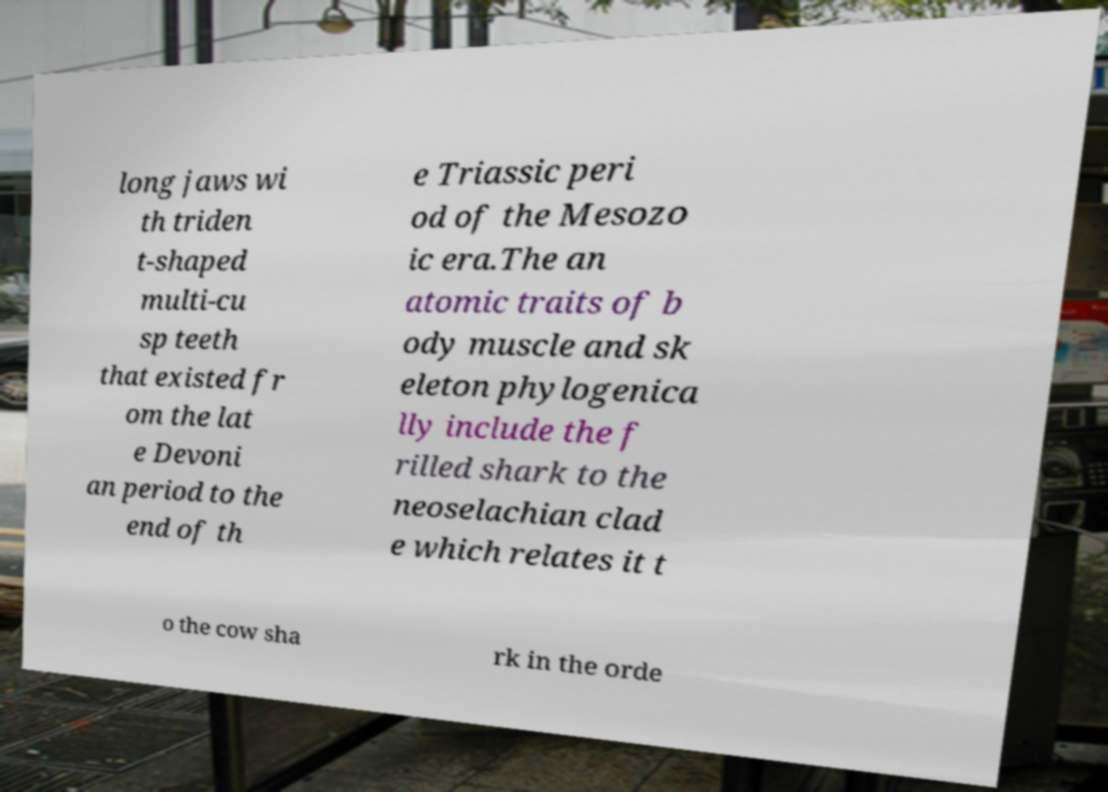There's text embedded in this image that I need extracted. Can you transcribe it verbatim? long jaws wi th triden t-shaped multi-cu sp teeth that existed fr om the lat e Devoni an period to the end of th e Triassic peri od of the Mesozo ic era.The an atomic traits of b ody muscle and sk eleton phylogenica lly include the f rilled shark to the neoselachian clad e which relates it t o the cow sha rk in the orde 